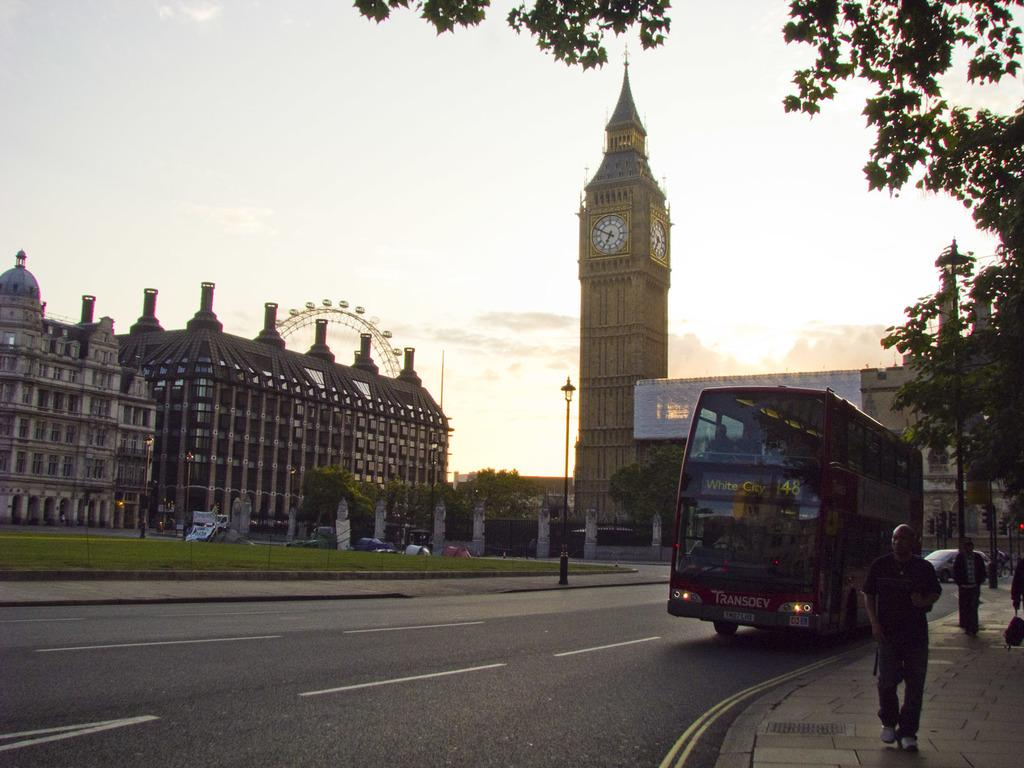<image>
Write a terse but informative summary of the picture. The double decker bus stopped in front of Big Ben is headed to White City. 